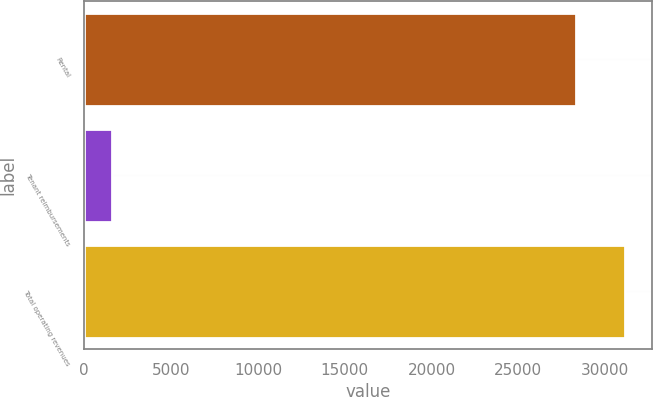Convert chart. <chart><loc_0><loc_0><loc_500><loc_500><bar_chart><fcel>Rental<fcel>Tenant reimbursements<fcel>Total operating revenues<nl><fcel>28320<fcel>1605<fcel>31152<nl></chart> 